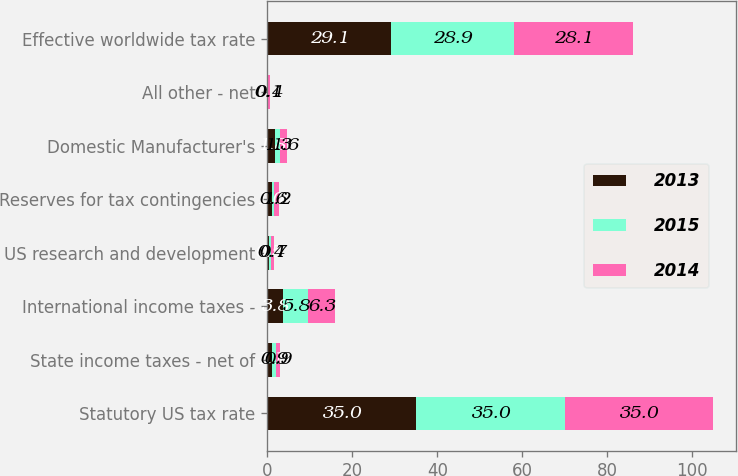<chart> <loc_0><loc_0><loc_500><loc_500><stacked_bar_chart><ecel><fcel>Statutory US tax rate<fcel>State income taxes - net of<fcel>International income taxes -<fcel>US research and development<fcel>Reserves for tax contingencies<fcel>Domestic Manufacturer's<fcel>All other - net<fcel>Effective worldwide tax rate<nl><fcel>2013<fcel>35<fcel>1.1<fcel>3.8<fcel>0.5<fcel>1<fcel>1.8<fcel>0.1<fcel>29.1<nl><fcel>2015<fcel>35<fcel>0.9<fcel>5.8<fcel>0.4<fcel>0.6<fcel>1.3<fcel>0.1<fcel>28.9<nl><fcel>2014<fcel>35<fcel>0.9<fcel>6.3<fcel>0.7<fcel>1.2<fcel>1.6<fcel>0.4<fcel>28.1<nl></chart> 